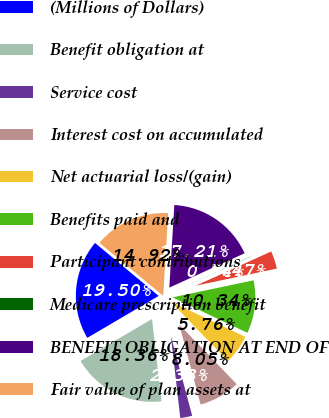Convert chart. <chart><loc_0><loc_0><loc_500><loc_500><pie_chart><fcel>(Millions of Dollars)<fcel>Benefit obligation at<fcel>Service cost<fcel>Interest cost on accumulated<fcel>Net actuarial loss/(gain)<fcel>Benefits paid and<fcel>Participant contributions<fcel>Medicare prescription benefit<fcel>BENEFIT OBLIGATION AT END OF<fcel>Fair value of plan assets at<nl><fcel>19.5%<fcel>18.36%<fcel>2.33%<fcel>8.05%<fcel>5.76%<fcel>10.34%<fcel>3.47%<fcel>0.04%<fcel>17.21%<fcel>14.92%<nl></chart> 